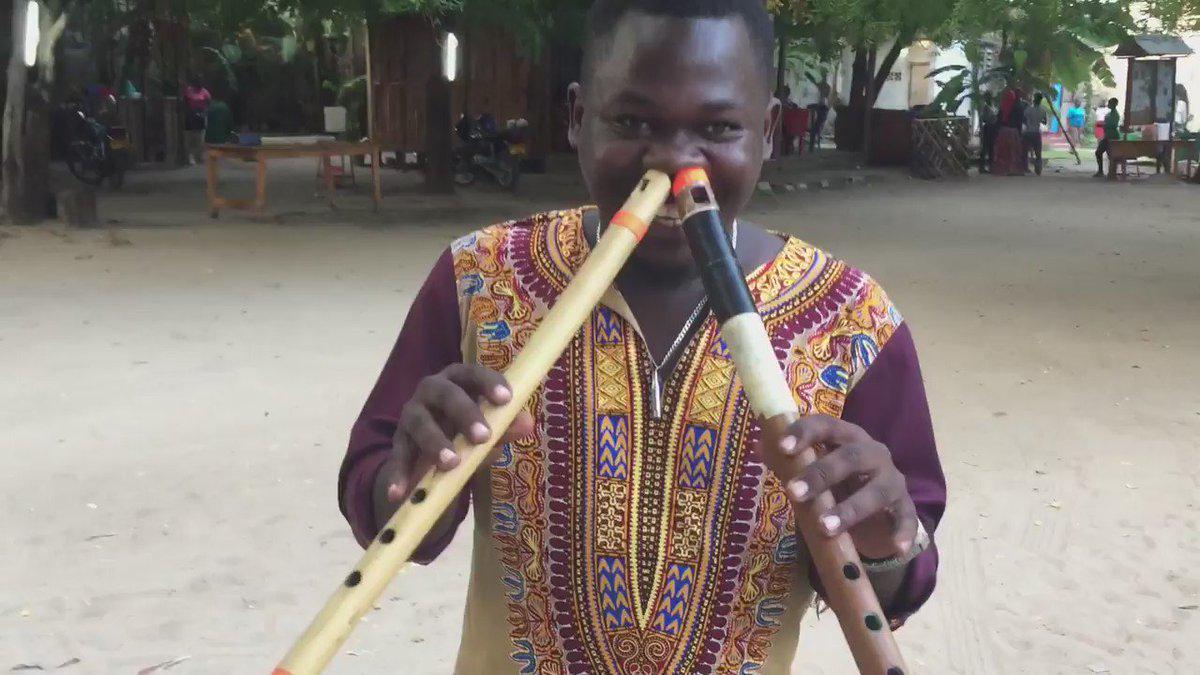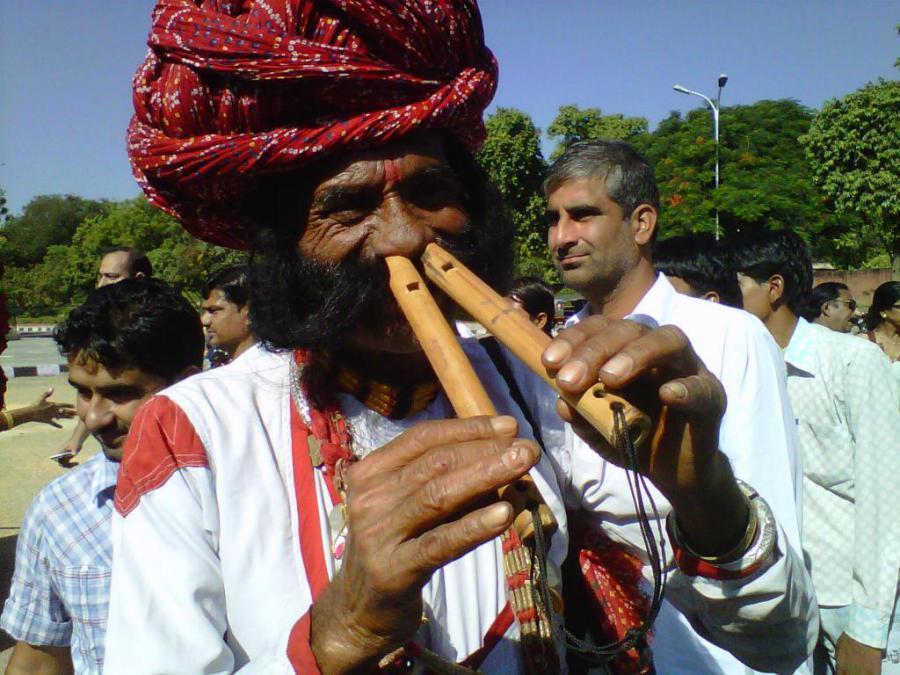The first image is the image on the left, the second image is the image on the right. Considering the images on both sides, is "Two of the images shows to two girls standing side-by-side playing the flute." valid? Answer yes or no. No. The first image is the image on the left, the second image is the image on the right. Analyze the images presented: Is the assertion "One person is playing two instruments at once in the image on the left." valid? Answer yes or no. Yes. 